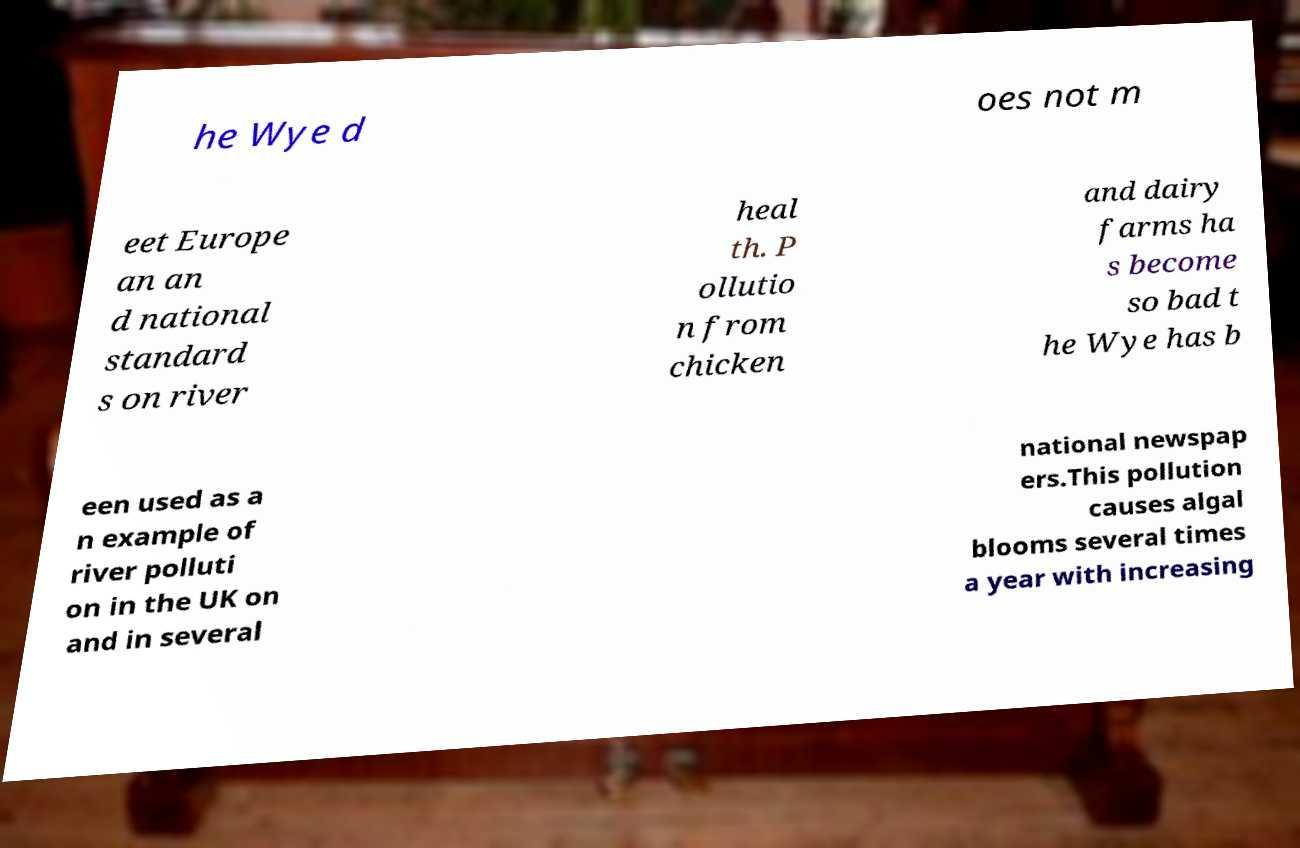There's text embedded in this image that I need extracted. Can you transcribe it verbatim? he Wye d oes not m eet Europe an an d national standard s on river heal th. P ollutio n from chicken and dairy farms ha s become so bad t he Wye has b een used as a n example of river polluti on in the UK on and in several national newspap ers.This pollution causes algal blooms several times a year with increasing 